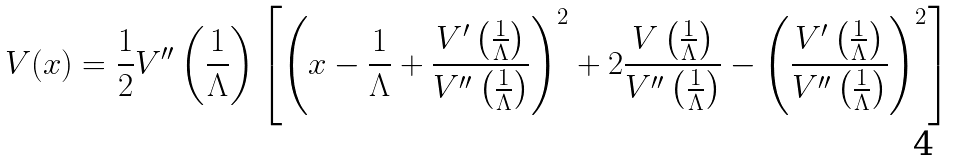Convert formula to latex. <formula><loc_0><loc_0><loc_500><loc_500>V ( x ) = \frac { 1 } { 2 } V ^ { \prime \prime } \left ( \frac { 1 } { \Lambda } \right ) \left [ \left ( x - \frac { 1 } { \Lambda } + \frac { V ^ { \prime } \left ( \frac { 1 } { \Lambda } \right ) } { V ^ { \prime \prime } \left ( \frac { 1 } { \Lambda } \right ) } \right ) ^ { 2 } + 2 \frac { V \left ( \frac { 1 } { \Lambda } \right ) } { V ^ { \prime \prime } \left ( \frac { 1 } { \Lambda } \right ) } - \left ( \frac { V ^ { \prime } \left ( \frac { 1 } { \Lambda } \right ) } { V ^ { \prime \prime } \left ( \frac { 1 } { \Lambda } \right ) } \right ) ^ { 2 } \right ]</formula> 